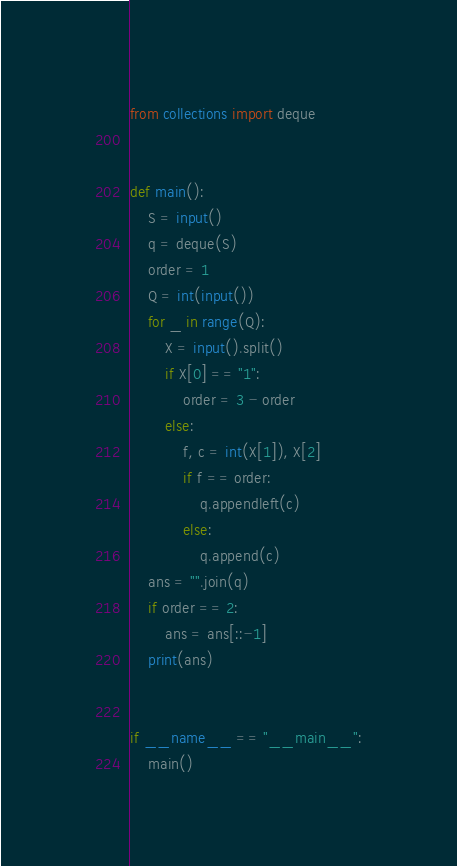Convert code to text. <code><loc_0><loc_0><loc_500><loc_500><_Python_>from collections import deque


def main():
    S = input()
    q = deque(S)
    order = 1
    Q = int(input())
    for _ in range(Q):
        X = input().split()
        if X[0] == "1":
            order = 3 - order
        else:
            f, c = int(X[1]), X[2]
            if f == order:
                q.appendleft(c)
            else:
                q.append(c)
    ans = "".join(q)
    if order == 2:
        ans = ans[::-1]
    print(ans)


if __name__ == "__main__":
    main()
</code> 